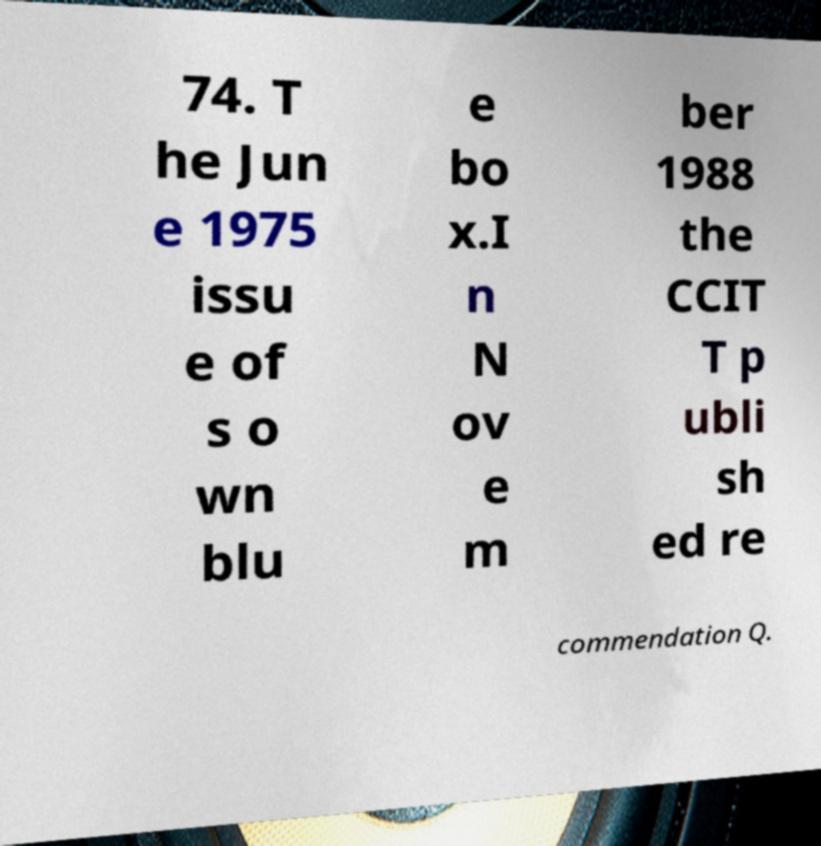Could you assist in decoding the text presented in this image and type it out clearly? 74. T he Jun e 1975 issu e of s o wn blu e bo x.I n N ov e m ber 1988 the CCIT T p ubli sh ed re commendation Q. 